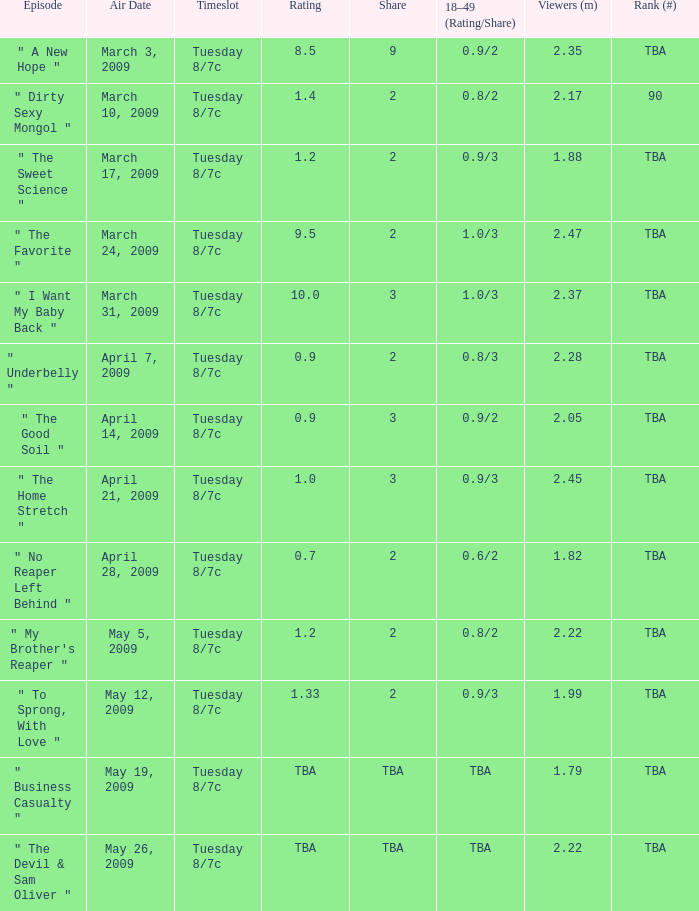What is the percentage of the 18-49 (rating/share) of 2.0. 